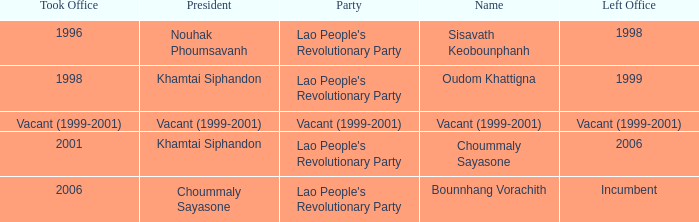What is Name, when President is Khamtai Siphandon, and when Left Office is 1999? Oudom Khattigna. 